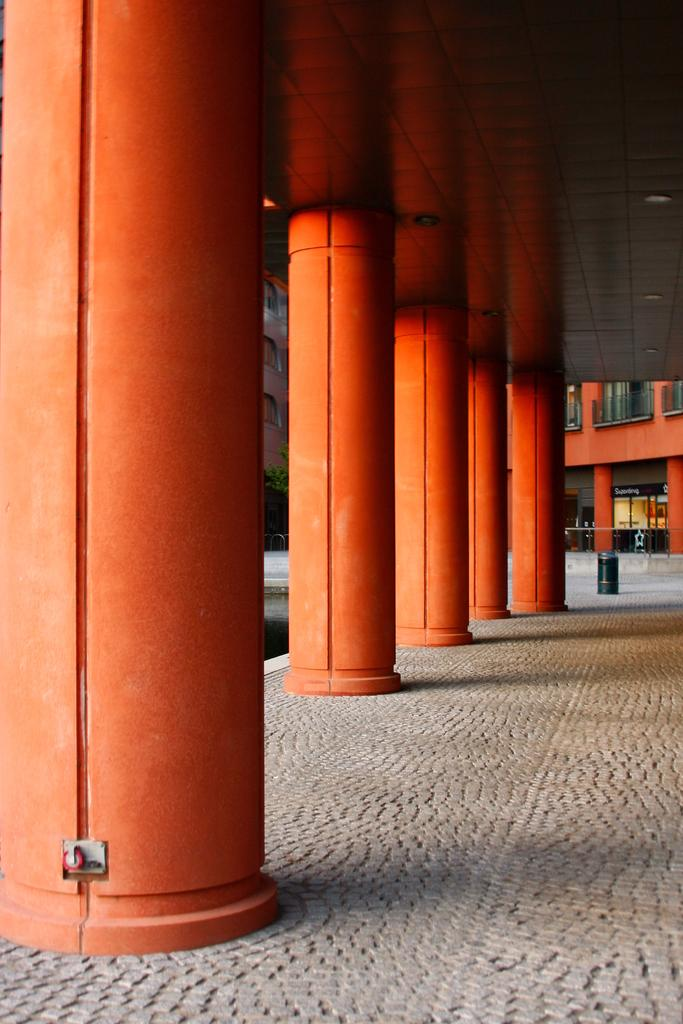What is the color of the pillars in the image? The pillars in the image are orange-colored. What type of natural element can be seen in the image? There is a tree in the image. What type of man-made structure is present in the image? There is a building in the image. Is there any text or writing visible in the image? Yes, there is text or writing visible in the image. What type of bottle is being used to celebrate the birthday in the image? There is no bottle or birthday celebration present in the image. What account number is associated with the text or writing visible in the image? There is no account number mentioned or visible in the image. 